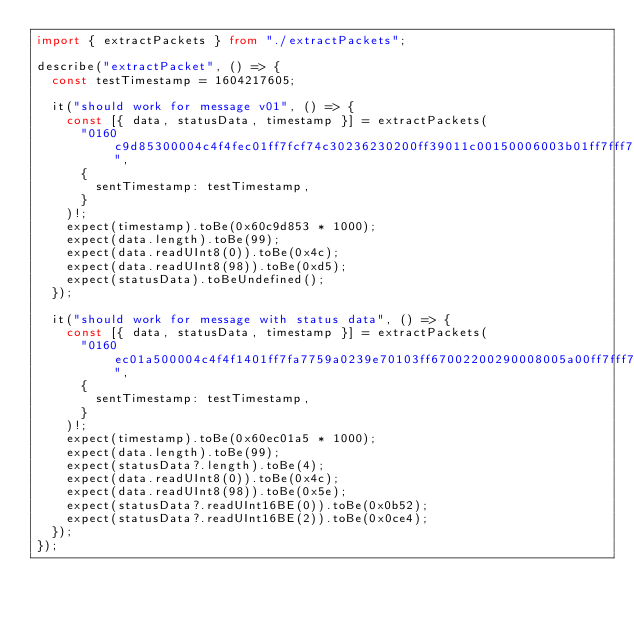Convert code to text. <code><loc_0><loc_0><loc_500><loc_500><_TypeScript_>import { extractPackets } from "./extractPackets";

describe("extractPacket", () => {
  const testTimestamp = 1604217605;

  it("should work for message v01", () => {
    const [{ data, statusData, timestamp }] = extractPackets(
      "0160c9d85300004c4f4fec01ff7fcf74c30236230200ff39011c00150006003b01ff7fff7f3100ff50ff37003700ff000000ffff7f0000ffff02000000010000000200020000dfff896c896ce074ff060b0a1500081338060909ff7fff7fff7fff7fff7fff7f0a0dcdd5",
      {
        sentTimestamp: testTimestamp,
      }
    )!;
    expect(timestamp).toBe(0x60c9d853 * 1000);
    expect(data.length).toBe(99);
    expect(data.readUInt8(0)).toBe(0x4c);
    expect(data.readUInt8(98)).toBe(0xd5);
    expect(statusData).toBeUndefined();
  });

  it("should work for message with status data", () => {
    const [{ data, statusData, timestamp }] = extractPackets(
      "0160ec01a500004c4f4f1401ff7fa7759a0239e70103ff67002200290008005a00ff7fff7f2f00ff5eff31003000ff000000ffff7f0000ffff01000000000000000100020000dfff406d406da275ff0016021302020132070909ff7fff7fff7fff7fff7fff7f0a0d175e0b520ce4",
      {
        sentTimestamp: testTimestamp,
      }
    )!;
    expect(timestamp).toBe(0x60ec01a5 * 1000);
    expect(data.length).toBe(99);
    expect(statusData?.length).toBe(4);
    expect(data.readUInt8(0)).toBe(0x4c);
    expect(data.readUInt8(98)).toBe(0x5e);
    expect(statusData?.readUInt16BE(0)).toBe(0x0b52);
    expect(statusData?.readUInt16BE(2)).toBe(0x0ce4);
  });
});
</code> 